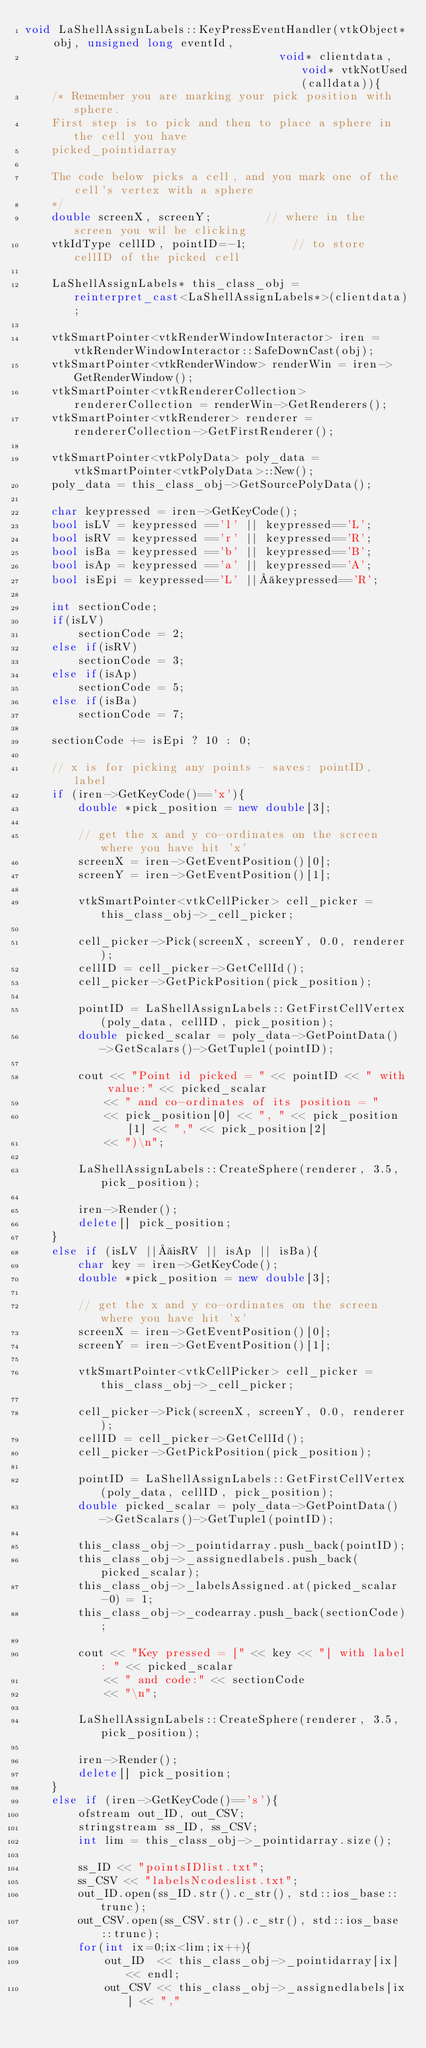Convert code to text. <code><loc_0><loc_0><loc_500><loc_500><_C++_>void LaShellAssignLabels::KeyPressEventHandler(vtkObject* obj, unsigned long eventId,
                                      void* clientdata, void* vtkNotUsed(calldata)){
	/* Remember you are marking your pick position with sphere.
	First step is to pick and then to place a sphere in the cell you have
	picked_pointidarray

	The code below picks a cell, and you mark one of the cell's vertex with a sphere
	*/
	double screenX, screenY;		// where in the screen you wil be clicking
	vtkIdType cellID, pointID=-1;		// to store cellID of the picked cell

	LaShellAssignLabels* this_class_obj = reinterpret_cast<LaShellAssignLabels*>(clientdata);

	vtkSmartPointer<vtkRenderWindowInteractor> iren = vtkRenderWindowInteractor::SafeDownCast(obj);
	vtkSmartPointer<vtkRenderWindow> renderWin = iren->GetRenderWindow();
	vtkSmartPointer<vtkRendererCollection> rendererCollection = renderWin->GetRenderers();
	vtkSmartPointer<vtkRenderer> renderer = rendererCollection->GetFirstRenderer();

	vtkSmartPointer<vtkPolyData> poly_data = vtkSmartPointer<vtkPolyData>::New();
	poly_data = this_class_obj->GetSourcePolyData();

	char keypressed = iren->GetKeyCode();
	bool isLV = keypressed =='l' || keypressed=='L';
	bool isRV = keypressed =='r' || keypressed=='R';
	bool isBa = keypressed =='b' || keypressed=='B';
	bool isAp = keypressed =='a' || keypressed=='A';
	bool isEpi = keypressed=='L' || keypressed=='R';

	int sectionCode;
	if(isLV)
		sectionCode = 2;
	else if(isRV)
		sectionCode = 3;
	else if(isAp)
		sectionCode = 5;
	else if(isBa)
		sectionCode = 7;

	sectionCode += isEpi ? 10 : 0;

	// x is for picking any points - saves: pointID, label
	if (iren->GetKeyCode()=='x'){
		double *pick_position = new double[3];

		// get the x and y co-ordinates on the screen where you have hit 'x'
		screenX = iren->GetEventPosition()[0];
		screenY = iren->GetEventPosition()[1];

		vtkSmartPointer<vtkCellPicker> cell_picker = this_class_obj->_cell_picker;

		cell_picker->Pick(screenX, screenY, 0.0, renderer);
		cellID = cell_picker->GetCellId();
		cell_picker->GetPickPosition(pick_position);

		pointID = LaShellAssignLabels::GetFirstCellVertex(poly_data, cellID, pick_position);
		double picked_scalar = poly_data->GetPointData()->GetScalars()->GetTuple1(pointID);

		cout << "Point id picked = " << pointID << " with value:" << picked_scalar
			<< " and co-ordinates of its position = "
			<< pick_position[0] << ", " << pick_position[1] << "," << pick_position[2]
			<< ")\n";

		LaShellAssignLabels::CreateSphere(renderer, 3.5, pick_position);

		iren->Render();
		delete[] pick_position;
	}
	else if (isLV || isRV || isAp || isBa){
		char key = iren->GetKeyCode();
		double *pick_position = new double[3];

		// get the x and y co-ordinates on the screen where you have hit 'x'
		screenX = iren->GetEventPosition()[0];
		screenY = iren->GetEventPosition()[1];

		vtkSmartPointer<vtkCellPicker> cell_picker = this_class_obj->_cell_picker;

		cell_picker->Pick(screenX, screenY, 0.0, renderer);
		cellID = cell_picker->GetCellId();
		cell_picker->GetPickPosition(pick_position);

		pointID = LaShellAssignLabels::GetFirstCellVertex(poly_data, cellID, pick_position);
		double picked_scalar = poly_data->GetPointData()->GetScalars()->GetTuple1(pointID);

		this_class_obj->_pointidarray.push_back(pointID);
		this_class_obj->_assignedlabels.push_back(picked_scalar);
		this_class_obj->_labelsAssigned.at(picked_scalar-0) = 1;
		this_class_obj->_codearray.push_back(sectionCode);

		cout << "Key pressed = [" << key << "] with label: " << picked_scalar
			<< " and code:" << sectionCode
			<< "\n";

		LaShellAssignLabels::CreateSphere(renderer, 3.5, pick_position);

		iren->Render();
		delete[] pick_position;
	}
	else if (iren->GetKeyCode()=='s'){
		ofstream out_ID, out_CSV;
		stringstream ss_ID, ss_CSV;
		int lim = this_class_obj->_pointidarray.size();

		ss_ID << "pointsIDlist.txt";
		ss_CSV << "labelsNcodeslist.txt";
		out_ID.open(ss_ID.str().c_str(), std::ios_base::trunc);
		out_CSV.open(ss_CSV.str().c_str(), std::ios_base::trunc);
		for(int ix=0;ix<lim;ix++){
			out_ID  << this_class_obj->_pointidarray[ix] << endl;
			out_CSV << this_class_obj->_assignedlabels[ix] << ","</code> 